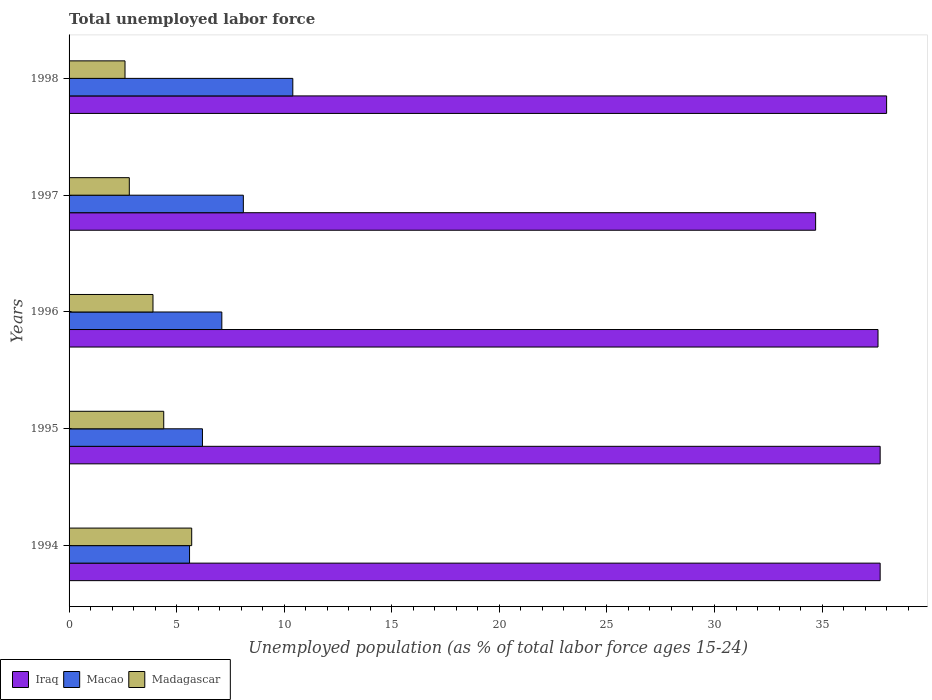How many groups of bars are there?
Your answer should be compact. 5. Are the number of bars per tick equal to the number of legend labels?
Your answer should be very brief. Yes. Are the number of bars on each tick of the Y-axis equal?
Provide a short and direct response. Yes. How many bars are there on the 1st tick from the top?
Your answer should be compact. 3. In how many cases, is the number of bars for a given year not equal to the number of legend labels?
Ensure brevity in your answer.  0. What is the percentage of unemployed population in in Macao in 1998?
Your answer should be very brief. 10.4. Across all years, what is the maximum percentage of unemployed population in in Iraq?
Make the answer very short. 38. Across all years, what is the minimum percentage of unemployed population in in Macao?
Offer a very short reply. 5.6. In which year was the percentage of unemployed population in in Madagascar maximum?
Offer a terse response. 1994. In which year was the percentage of unemployed population in in Madagascar minimum?
Your answer should be very brief. 1998. What is the total percentage of unemployed population in in Iraq in the graph?
Provide a succinct answer. 185.7. What is the difference between the percentage of unemployed population in in Iraq in 1995 and that in 1997?
Ensure brevity in your answer.  3. What is the difference between the percentage of unemployed population in in Madagascar in 1996 and the percentage of unemployed population in in Macao in 1998?
Your answer should be very brief. -6.5. What is the average percentage of unemployed population in in Iraq per year?
Provide a short and direct response. 37.14. In the year 1994, what is the difference between the percentage of unemployed population in in Macao and percentage of unemployed population in in Iraq?
Your answer should be compact. -32.1. What is the ratio of the percentage of unemployed population in in Macao in 1995 to that in 1998?
Give a very brief answer. 0.6. What is the difference between the highest and the second highest percentage of unemployed population in in Madagascar?
Your answer should be compact. 1.3. What is the difference between the highest and the lowest percentage of unemployed population in in Madagascar?
Your response must be concise. 3.1. Is the sum of the percentage of unemployed population in in Iraq in 1994 and 1995 greater than the maximum percentage of unemployed population in in Madagascar across all years?
Your answer should be compact. Yes. What does the 2nd bar from the top in 1997 represents?
Keep it short and to the point. Macao. What does the 3rd bar from the bottom in 1998 represents?
Keep it short and to the point. Madagascar. Is it the case that in every year, the sum of the percentage of unemployed population in in Macao and percentage of unemployed population in in Iraq is greater than the percentage of unemployed population in in Madagascar?
Your answer should be very brief. Yes. Does the graph contain any zero values?
Provide a succinct answer. No. Where does the legend appear in the graph?
Offer a terse response. Bottom left. What is the title of the graph?
Offer a very short reply. Total unemployed labor force. What is the label or title of the X-axis?
Make the answer very short. Unemployed population (as % of total labor force ages 15-24). What is the Unemployed population (as % of total labor force ages 15-24) of Iraq in 1994?
Your answer should be compact. 37.7. What is the Unemployed population (as % of total labor force ages 15-24) in Macao in 1994?
Your answer should be very brief. 5.6. What is the Unemployed population (as % of total labor force ages 15-24) of Madagascar in 1994?
Provide a short and direct response. 5.7. What is the Unemployed population (as % of total labor force ages 15-24) of Iraq in 1995?
Provide a succinct answer. 37.7. What is the Unemployed population (as % of total labor force ages 15-24) of Macao in 1995?
Your answer should be compact. 6.2. What is the Unemployed population (as % of total labor force ages 15-24) in Madagascar in 1995?
Keep it short and to the point. 4.4. What is the Unemployed population (as % of total labor force ages 15-24) of Iraq in 1996?
Your response must be concise. 37.6. What is the Unemployed population (as % of total labor force ages 15-24) in Macao in 1996?
Make the answer very short. 7.1. What is the Unemployed population (as % of total labor force ages 15-24) of Madagascar in 1996?
Ensure brevity in your answer.  3.9. What is the Unemployed population (as % of total labor force ages 15-24) of Iraq in 1997?
Ensure brevity in your answer.  34.7. What is the Unemployed population (as % of total labor force ages 15-24) in Macao in 1997?
Give a very brief answer. 8.1. What is the Unemployed population (as % of total labor force ages 15-24) in Madagascar in 1997?
Make the answer very short. 2.8. What is the Unemployed population (as % of total labor force ages 15-24) in Macao in 1998?
Your answer should be compact. 10.4. What is the Unemployed population (as % of total labor force ages 15-24) in Madagascar in 1998?
Keep it short and to the point. 2.6. Across all years, what is the maximum Unemployed population (as % of total labor force ages 15-24) in Iraq?
Your response must be concise. 38. Across all years, what is the maximum Unemployed population (as % of total labor force ages 15-24) of Macao?
Keep it short and to the point. 10.4. Across all years, what is the maximum Unemployed population (as % of total labor force ages 15-24) in Madagascar?
Provide a succinct answer. 5.7. Across all years, what is the minimum Unemployed population (as % of total labor force ages 15-24) in Iraq?
Your answer should be very brief. 34.7. Across all years, what is the minimum Unemployed population (as % of total labor force ages 15-24) in Macao?
Offer a terse response. 5.6. Across all years, what is the minimum Unemployed population (as % of total labor force ages 15-24) of Madagascar?
Your answer should be compact. 2.6. What is the total Unemployed population (as % of total labor force ages 15-24) in Iraq in the graph?
Offer a very short reply. 185.7. What is the total Unemployed population (as % of total labor force ages 15-24) in Macao in the graph?
Offer a terse response. 37.4. What is the difference between the Unemployed population (as % of total labor force ages 15-24) of Macao in 1994 and that in 1995?
Your answer should be very brief. -0.6. What is the difference between the Unemployed population (as % of total labor force ages 15-24) of Madagascar in 1994 and that in 1995?
Your answer should be very brief. 1.3. What is the difference between the Unemployed population (as % of total labor force ages 15-24) in Iraq in 1994 and that in 1996?
Your answer should be compact. 0.1. What is the difference between the Unemployed population (as % of total labor force ages 15-24) in Macao in 1994 and that in 1996?
Offer a very short reply. -1.5. What is the difference between the Unemployed population (as % of total labor force ages 15-24) of Madagascar in 1994 and that in 1996?
Ensure brevity in your answer.  1.8. What is the difference between the Unemployed population (as % of total labor force ages 15-24) in Iraq in 1994 and that in 1997?
Ensure brevity in your answer.  3. What is the difference between the Unemployed population (as % of total labor force ages 15-24) of Madagascar in 1994 and that in 1997?
Offer a very short reply. 2.9. What is the difference between the Unemployed population (as % of total labor force ages 15-24) in Iraq in 1994 and that in 1998?
Your answer should be very brief. -0.3. What is the difference between the Unemployed population (as % of total labor force ages 15-24) of Macao in 1994 and that in 1998?
Provide a short and direct response. -4.8. What is the difference between the Unemployed population (as % of total labor force ages 15-24) of Iraq in 1995 and that in 1997?
Provide a succinct answer. 3. What is the difference between the Unemployed population (as % of total labor force ages 15-24) in Iraq in 1995 and that in 1998?
Give a very brief answer. -0.3. What is the difference between the Unemployed population (as % of total labor force ages 15-24) in Macao in 1995 and that in 1998?
Offer a terse response. -4.2. What is the difference between the Unemployed population (as % of total labor force ages 15-24) in Madagascar in 1995 and that in 1998?
Your response must be concise. 1.8. What is the difference between the Unemployed population (as % of total labor force ages 15-24) in Iraq in 1996 and that in 1997?
Your response must be concise. 2.9. What is the difference between the Unemployed population (as % of total labor force ages 15-24) of Iraq in 1996 and that in 1998?
Offer a terse response. -0.4. What is the difference between the Unemployed population (as % of total labor force ages 15-24) of Macao in 1996 and that in 1998?
Provide a succinct answer. -3.3. What is the difference between the Unemployed population (as % of total labor force ages 15-24) in Madagascar in 1996 and that in 1998?
Offer a terse response. 1.3. What is the difference between the Unemployed population (as % of total labor force ages 15-24) in Iraq in 1994 and the Unemployed population (as % of total labor force ages 15-24) in Macao in 1995?
Make the answer very short. 31.5. What is the difference between the Unemployed population (as % of total labor force ages 15-24) of Iraq in 1994 and the Unemployed population (as % of total labor force ages 15-24) of Madagascar in 1995?
Your response must be concise. 33.3. What is the difference between the Unemployed population (as % of total labor force ages 15-24) of Iraq in 1994 and the Unemployed population (as % of total labor force ages 15-24) of Macao in 1996?
Your response must be concise. 30.6. What is the difference between the Unemployed population (as % of total labor force ages 15-24) in Iraq in 1994 and the Unemployed population (as % of total labor force ages 15-24) in Madagascar in 1996?
Your answer should be very brief. 33.8. What is the difference between the Unemployed population (as % of total labor force ages 15-24) of Macao in 1994 and the Unemployed population (as % of total labor force ages 15-24) of Madagascar in 1996?
Make the answer very short. 1.7. What is the difference between the Unemployed population (as % of total labor force ages 15-24) in Iraq in 1994 and the Unemployed population (as % of total labor force ages 15-24) in Macao in 1997?
Give a very brief answer. 29.6. What is the difference between the Unemployed population (as % of total labor force ages 15-24) of Iraq in 1994 and the Unemployed population (as % of total labor force ages 15-24) of Madagascar in 1997?
Keep it short and to the point. 34.9. What is the difference between the Unemployed population (as % of total labor force ages 15-24) in Macao in 1994 and the Unemployed population (as % of total labor force ages 15-24) in Madagascar in 1997?
Provide a succinct answer. 2.8. What is the difference between the Unemployed population (as % of total labor force ages 15-24) of Iraq in 1994 and the Unemployed population (as % of total labor force ages 15-24) of Macao in 1998?
Your answer should be very brief. 27.3. What is the difference between the Unemployed population (as % of total labor force ages 15-24) in Iraq in 1994 and the Unemployed population (as % of total labor force ages 15-24) in Madagascar in 1998?
Make the answer very short. 35.1. What is the difference between the Unemployed population (as % of total labor force ages 15-24) in Iraq in 1995 and the Unemployed population (as % of total labor force ages 15-24) in Macao in 1996?
Offer a very short reply. 30.6. What is the difference between the Unemployed population (as % of total labor force ages 15-24) in Iraq in 1995 and the Unemployed population (as % of total labor force ages 15-24) in Madagascar in 1996?
Your answer should be compact. 33.8. What is the difference between the Unemployed population (as % of total labor force ages 15-24) of Macao in 1995 and the Unemployed population (as % of total labor force ages 15-24) of Madagascar in 1996?
Provide a short and direct response. 2.3. What is the difference between the Unemployed population (as % of total labor force ages 15-24) of Iraq in 1995 and the Unemployed population (as % of total labor force ages 15-24) of Macao in 1997?
Provide a succinct answer. 29.6. What is the difference between the Unemployed population (as % of total labor force ages 15-24) of Iraq in 1995 and the Unemployed population (as % of total labor force ages 15-24) of Madagascar in 1997?
Give a very brief answer. 34.9. What is the difference between the Unemployed population (as % of total labor force ages 15-24) in Iraq in 1995 and the Unemployed population (as % of total labor force ages 15-24) in Macao in 1998?
Keep it short and to the point. 27.3. What is the difference between the Unemployed population (as % of total labor force ages 15-24) in Iraq in 1995 and the Unemployed population (as % of total labor force ages 15-24) in Madagascar in 1998?
Give a very brief answer. 35.1. What is the difference between the Unemployed population (as % of total labor force ages 15-24) of Macao in 1995 and the Unemployed population (as % of total labor force ages 15-24) of Madagascar in 1998?
Your response must be concise. 3.6. What is the difference between the Unemployed population (as % of total labor force ages 15-24) in Iraq in 1996 and the Unemployed population (as % of total labor force ages 15-24) in Macao in 1997?
Make the answer very short. 29.5. What is the difference between the Unemployed population (as % of total labor force ages 15-24) of Iraq in 1996 and the Unemployed population (as % of total labor force ages 15-24) of Madagascar in 1997?
Provide a short and direct response. 34.8. What is the difference between the Unemployed population (as % of total labor force ages 15-24) of Macao in 1996 and the Unemployed population (as % of total labor force ages 15-24) of Madagascar in 1997?
Your answer should be very brief. 4.3. What is the difference between the Unemployed population (as % of total labor force ages 15-24) of Iraq in 1996 and the Unemployed population (as % of total labor force ages 15-24) of Macao in 1998?
Offer a terse response. 27.2. What is the difference between the Unemployed population (as % of total labor force ages 15-24) in Macao in 1996 and the Unemployed population (as % of total labor force ages 15-24) in Madagascar in 1998?
Ensure brevity in your answer.  4.5. What is the difference between the Unemployed population (as % of total labor force ages 15-24) in Iraq in 1997 and the Unemployed population (as % of total labor force ages 15-24) in Macao in 1998?
Provide a short and direct response. 24.3. What is the difference between the Unemployed population (as % of total labor force ages 15-24) in Iraq in 1997 and the Unemployed population (as % of total labor force ages 15-24) in Madagascar in 1998?
Provide a succinct answer. 32.1. What is the average Unemployed population (as % of total labor force ages 15-24) of Iraq per year?
Give a very brief answer. 37.14. What is the average Unemployed population (as % of total labor force ages 15-24) in Macao per year?
Offer a very short reply. 7.48. What is the average Unemployed population (as % of total labor force ages 15-24) in Madagascar per year?
Offer a very short reply. 3.88. In the year 1994, what is the difference between the Unemployed population (as % of total labor force ages 15-24) in Iraq and Unemployed population (as % of total labor force ages 15-24) in Macao?
Ensure brevity in your answer.  32.1. In the year 1994, what is the difference between the Unemployed population (as % of total labor force ages 15-24) of Iraq and Unemployed population (as % of total labor force ages 15-24) of Madagascar?
Keep it short and to the point. 32. In the year 1994, what is the difference between the Unemployed population (as % of total labor force ages 15-24) in Macao and Unemployed population (as % of total labor force ages 15-24) in Madagascar?
Ensure brevity in your answer.  -0.1. In the year 1995, what is the difference between the Unemployed population (as % of total labor force ages 15-24) of Iraq and Unemployed population (as % of total labor force ages 15-24) of Macao?
Provide a short and direct response. 31.5. In the year 1995, what is the difference between the Unemployed population (as % of total labor force ages 15-24) in Iraq and Unemployed population (as % of total labor force ages 15-24) in Madagascar?
Offer a terse response. 33.3. In the year 1995, what is the difference between the Unemployed population (as % of total labor force ages 15-24) of Macao and Unemployed population (as % of total labor force ages 15-24) of Madagascar?
Offer a very short reply. 1.8. In the year 1996, what is the difference between the Unemployed population (as % of total labor force ages 15-24) in Iraq and Unemployed population (as % of total labor force ages 15-24) in Macao?
Provide a short and direct response. 30.5. In the year 1996, what is the difference between the Unemployed population (as % of total labor force ages 15-24) in Iraq and Unemployed population (as % of total labor force ages 15-24) in Madagascar?
Keep it short and to the point. 33.7. In the year 1996, what is the difference between the Unemployed population (as % of total labor force ages 15-24) in Macao and Unemployed population (as % of total labor force ages 15-24) in Madagascar?
Your answer should be compact. 3.2. In the year 1997, what is the difference between the Unemployed population (as % of total labor force ages 15-24) of Iraq and Unemployed population (as % of total labor force ages 15-24) of Macao?
Make the answer very short. 26.6. In the year 1997, what is the difference between the Unemployed population (as % of total labor force ages 15-24) in Iraq and Unemployed population (as % of total labor force ages 15-24) in Madagascar?
Ensure brevity in your answer.  31.9. In the year 1997, what is the difference between the Unemployed population (as % of total labor force ages 15-24) of Macao and Unemployed population (as % of total labor force ages 15-24) of Madagascar?
Offer a very short reply. 5.3. In the year 1998, what is the difference between the Unemployed population (as % of total labor force ages 15-24) in Iraq and Unemployed population (as % of total labor force ages 15-24) in Macao?
Provide a short and direct response. 27.6. In the year 1998, what is the difference between the Unemployed population (as % of total labor force ages 15-24) in Iraq and Unemployed population (as % of total labor force ages 15-24) in Madagascar?
Offer a terse response. 35.4. What is the ratio of the Unemployed population (as % of total labor force ages 15-24) in Iraq in 1994 to that in 1995?
Give a very brief answer. 1. What is the ratio of the Unemployed population (as % of total labor force ages 15-24) of Macao in 1994 to that in 1995?
Make the answer very short. 0.9. What is the ratio of the Unemployed population (as % of total labor force ages 15-24) of Madagascar in 1994 to that in 1995?
Make the answer very short. 1.3. What is the ratio of the Unemployed population (as % of total labor force ages 15-24) of Iraq in 1994 to that in 1996?
Make the answer very short. 1. What is the ratio of the Unemployed population (as % of total labor force ages 15-24) of Macao in 1994 to that in 1996?
Provide a short and direct response. 0.79. What is the ratio of the Unemployed population (as % of total labor force ages 15-24) in Madagascar in 1994 to that in 1996?
Give a very brief answer. 1.46. What is the ratio of the Unemployed population (as % of total labor force ages 15-24) in Iraq in 1994 to that in 1997?
Offer a terse response. 1.09. What is the ratio of the Unemployed population (as % of total labor force ages 15-24) of Macao in 1994 to that in 1997?
Offer a terse response. 0.69. What is the ratio of the Unemployed population (as % of total labor force ages 15-24) in Madagascar in 1994 to that in 1997?
Make the answer very short. 2.04. What is the ratio of the Unemployed population (as % of total labor force ages 15-24) in Iraq in 1994 to that in 1998?
Offer a very short reply. 0.99. What is the ratio of the Unemployed population (as % of total labor force ages 15-24) of Macao in 1994 to that in 1998?
Offer a very short reply. 0.54. What is the ratio of the Unemployed population (as % of total labor force ages 15-24) of Madagascar in 1994 to that in 1998?
Offer a terse response. 2.19. What is the ratio of the Unemployed population (as % of total labor force ages 15-24) in Iraq in 1995 to that in 1996?
Ensure brevity in your answer.  1. What is the ratio of the Unemployed population (as % of total labor force ages 15-24) of Macao in 1995 to that in 1996?
Your response must be concise. 0.87. What is the ratio of the Unemployed population (as % of total labor force ages 15-24) of Madagascar in 1995 to that in 1996?
Ensure brevity in your answer.  1.13. What is the ratio of the Unemployed population (as % of total labor force ages 15-24) in Iraq in 1995 to that in 1997?
Provide a succinct answer. 1.09. What is the ratio of the Unemployed population (as % of total labor force ages 15-24) in Macao in 1995 to that in 1997?
Give a very brief answer. 0.77. What is the ratio of the Unemployed population (as % of total labor force ages 15-24) in Madagascar in 1995 to that in 1997?
Make the answer very short. 1.57. What is the ratio of the Unemployed population (as % of total labor force ages 15-24) of Macao in 1995 to that in 1998?
Make the answer very short. 0.6. What is the ratio of the Unemployed population (as % of total labor force ages 15-24) in Madagascar in 1995 to that in 1998?
Offer a terse response. 1.69. What is the ratio of the Unemployed population (as % of total labor force ages 15-24) in Iraq in 1996 to that in 1997?
Make the answer very short. 1.08. What is the ratio of the Unemployed population (as % of total labor force ages 15-24) in Macao in 1996 to that in 1997?
Provide a short and direct response. 0.88. What is the ratio of the Unemployed population (as % of total labor force ages 15-24) of Madagascar in 1996 to that in 1997?
Give a very brief answer. 1.39. What is the ratio of the Unemployed population (as % of total labor force ages 15-24) of Iraq in 1996 to that in 1998?
Your response must be concise. 0.99. What is the ratio of the Unemployed population (as % of total labor force ages 15-24) in Macao in 1996 to that in 1998?
Provide a short and direct response. 0.68. What is the ratio of the Unemployed population (as % of total labor force ages 15-24) in Iraq in 1997 to that in 1998?
Offer a very short reply. 0.91. What is the ratio of the Unemployed population (as % of total labor force ages 15-24) in Macao in 1997 to that in 1998?
Keep it short and to the point. 0.78. What is the difference between the highest and the second highest Unemployed population (as % of total labor force ages 15-24) of Iraq?
Your answer should be very brief. 0.3. What is the difference between the highest and the lowest Unemployed population (as % of total labor force ages 15-24) of Iraq?
Your answer should be compact. 3.3. What is the difference between the highest and the lowest Unemployed population (as % of total labor force ages 15-24) in Macao?
Give a very brief answer. 4.8. 